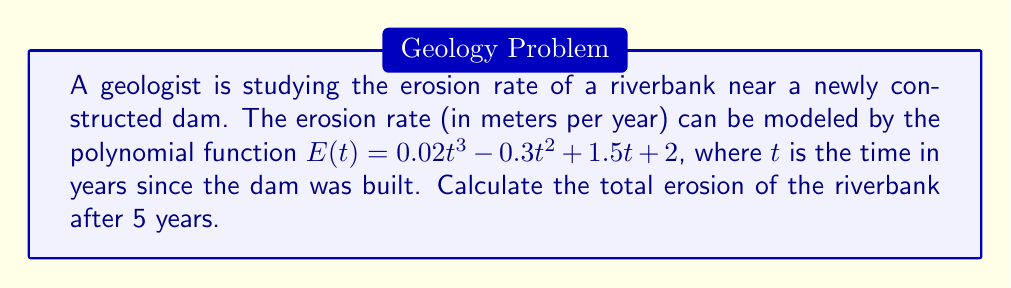Could you help me with this problem? To find the total erosion after 5 years, we need to integrate the erosion rate function $E(t)$ from $t=0$ to $t=5$. This will give us the area under the curve, which represents the total erosion over that time period.

1) First, let's integrate the function $E(t)$:
   $$\int E(t) dt = \int (0.02t^3 - 0.3t^2 + 1.5t + 2) dt$$
   $$= 0.005t^4 - 0.1t^3 + 0.75t^2 + 2t + C$$

2) Now, we need to evaluate this from $t=0$ to $t=5$. Let's call our antiderivative $F(t)$:
   $$\text{Total Erosion} = F(5) - F(0)$$

3) Calculate $F(5)$:
   $$F(5) = 0.005(5^4) - 0.1(5^3) + 0.75(5^2) + 2(5)$$
   $$= 3.125 - 12.5 + 18.75 + 10 = 19.375$$

4) Calculate $F(0)$:
   $$F(0) = 0.005(0^4) - 0.1(0^3) + 0.75(0^2) + 2(0) = 0$$

5) Therefore, the total erosion is:
   $$19.375 - 0 = 19.375 \text{ meters}$$
Answer: The total erosion of the riverbank after 5 years is 19.375 meters. 